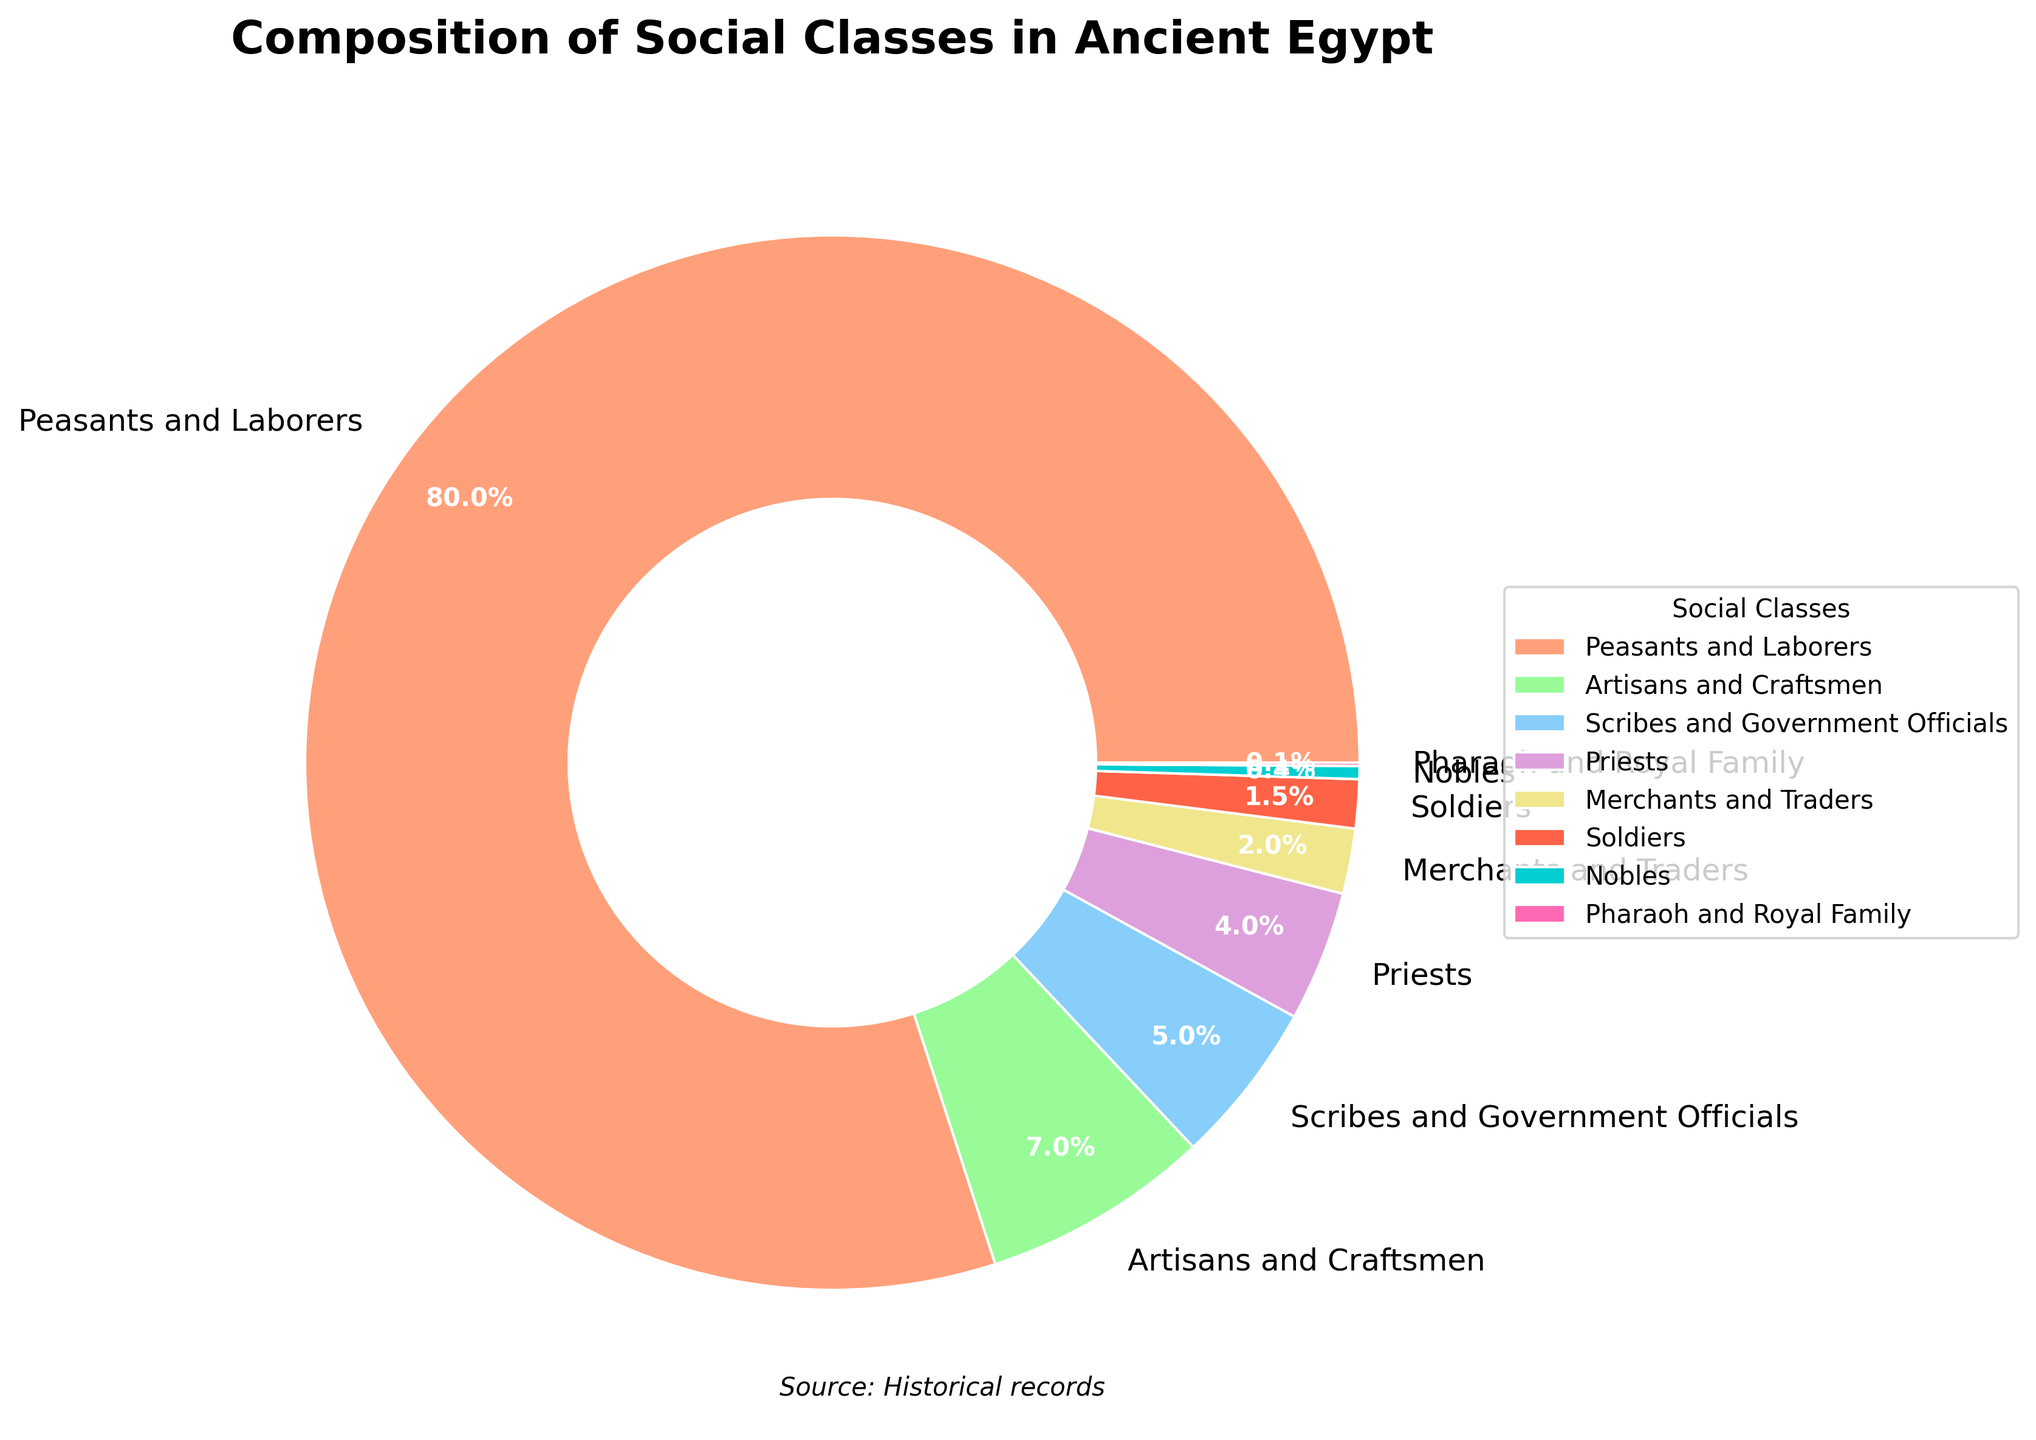What percentage of the population does the combination of Nobles and Priests account for? Add the percentage of Nobles (0.4%) to the percentage of Priests (4%): 0.4% + 4% = 4.4%
Answer: 4.4% Which social class has a larger population, Scribes and Government Officials or Artisans and Craftsmen? Compare the percentages: Scribes and Government Officials (5%) and Artisans and Craftsmen (7%). Since 7% > 5%, Artisans and Craftsmen have a larger population.
Answer: Artisans and Craftsmen What is the difference in population percentage between Merchants and Traders and Soldiers? Subtract the percentage of Soldiers (1.5%) from Merchants and Traders (2%): 2% - 1.5% = 0.5%
Answer: 0.5% What percentage of the population does not belong to Peasants and Laborers? Subtract the percentage of Peasants and Laborers (80%) from the total population (100%): 100% - 80% = 20%
Answer: 20% Of the social classes with less than 5% of the population, which one is closest to having 5%? Compare percentages less than 5%: Priests (4%), Merchants and Traders (2%), Soldiers (1.5%), Nobles (0.4%), Pharaoh and Royal Family (0.1%). Priests, with 4%, are closest to 5%.
Answer: Priests Which two social classes together account for more than 10% but less than 15% of the population? Examine combinations of social classes: Artisans and Craftsmen (7%) + Scribes and Government Officials (5%) = 12%. This falls between 10% and 15%.
Answer: Artisans and Craftsmen, Scribes and Government Officials In terms of population percentage, how does the Pharaoh and Royal Family compare to the Nobles? The Pharaoh and Royal Family have 0.1%, while Nobles have 0.4%. Since 0.1% < 0.4%, the Pharaoh and Royal Family are a smaller percentage.
Answer: Pharaoh and Royal Family are smaller Which social class accounts for the largest portion of the pie chart? The largest percentage is 80%, belonging to Peasants and Laborers.
Answer: Peasants and Laborers 